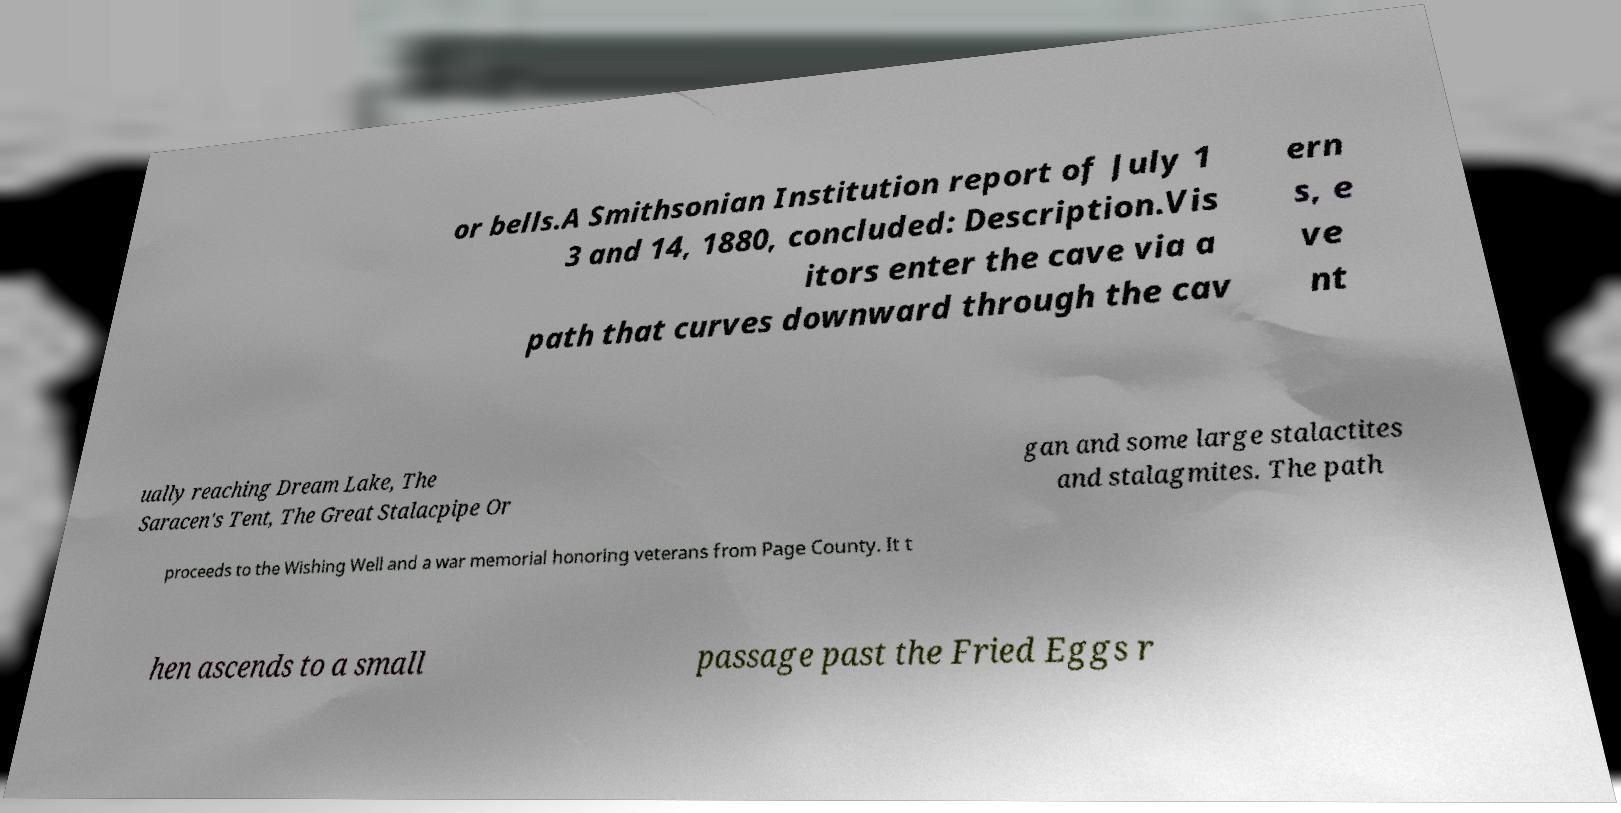Please read and relay the text visible in this image. What does it say? or bells.A Smithsonian Institution report of July 1 3 and 14, 1880, concluded: Description.Vis itors enter the cave via a path that curves downward through the cav ern s, e ve nt ually reaching Dream Lake, The Saracen's Tent, The Great Stalacpipe Or gan and some large stalactites and stalagmites. The path proceeds to the Wishing Well and a war memorial honoring veterans from Page County. It t hen ascends to a small passage past the Fried Eggs r 